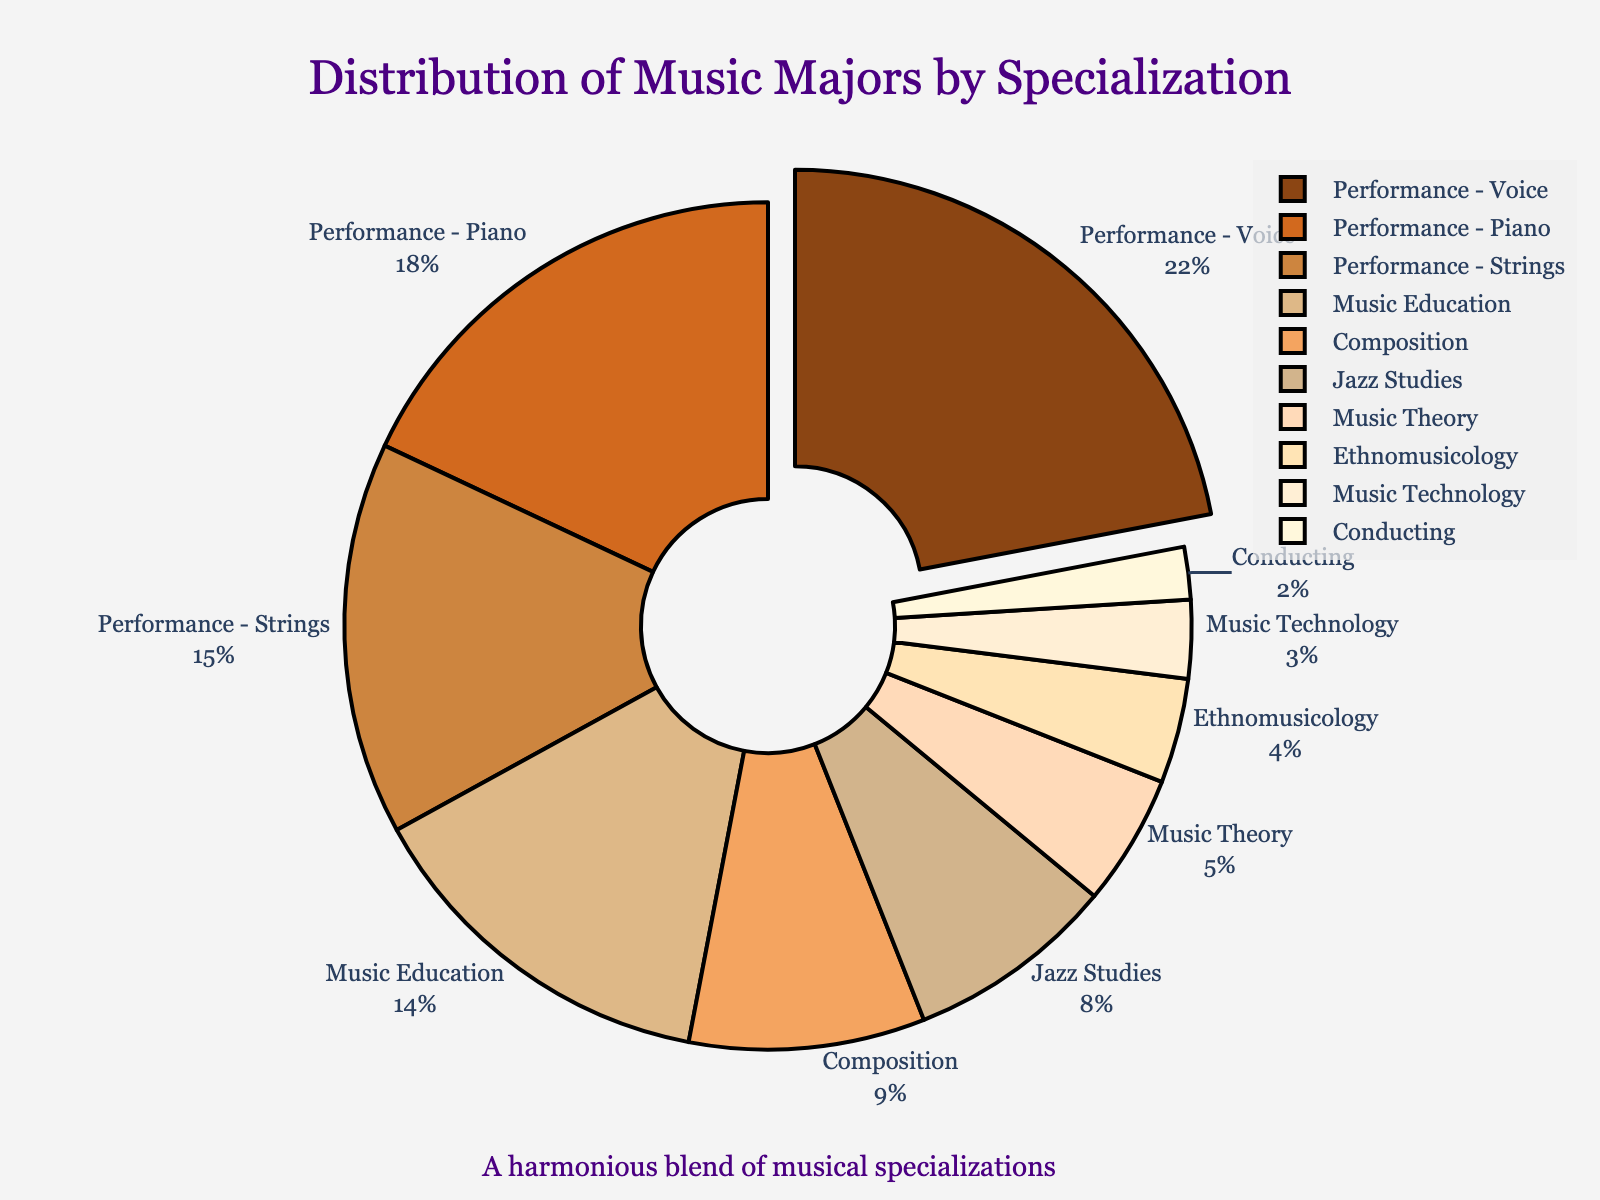Which specialization has the highest percentage of music majors? The figure highlights the largest section, which is Performance - Voice. The text information outside the pie also confirms this with 22%.
Answer: Performance - Voice Which specializations have a smaller percentage than Music Education? Music Education has 14%. Other specializations with percentages smaller than this are Composition (9%), Jazz Studies (8%), Music Theory (5%), Ethnomusicology (4%), Music Technology (3%), and Conducting (2%).
Answer: Composition, Jazz Studies, Music Theory, Ethnomusicology, Music Technology, Conducting How much more is the combined percentage of Performance - Voice and Performance - Piano compared to Jazz Studies? Performance - Voice is 22% and Performance - Piano is 18%, making a combined total of 40%. Jazz Studies is 8%, so the difference is 40% - 8% = 32%.
Answer: 32% How does the percentage of students in Music Theory compare to those in Jazz Studies? Music Theory has 5%, while Jazz Studies has 8%. Therefore, the percentage for Jazz Studies is higher.
Answer: Jazz Studies is higher What's the combined percentage of students in all performance-related specializations? The performance-related specializations are Voice (22%), Piano (18%), and Strings (15%). The combined percentage is 22% + 18% + 15% = 55%.
Answer: 55% Which specializations have a percentage that falls below 5%? Looking at the pie chart, specializations below 5% are Ethnomusicology (4%), Music Technology (3%), and Conducting (2%).
Answer: Ethnomusicology, Music Technology, Conducting By how much does the percentage of students in Composition exceed Conducting? Composition is 9%, and Conducting is 2%. The difference is 9% - 2% = 7%.
Answer: 7% If we combine the percentages of Music Theory and Ethnomusicology, how does it compare to Performance - Strings? Music Theory is 5%, and Ethnomusicology is 4%. Their combined percentage is 5% + 4% = 9%. Performance - Strings is 15%. Therefore, 15% - 9% = 6%, showing Performance - Strings exceeds the combined percentage by 6%.
Answer: Performance - Strings is higher by 6% Which portion of the pie chart is indicated as the most notable by being visually distinct? The largest portion, Performance - Voice at 22%, is pulled out from the pie chart for emphasis.
Answer: Performance - Voice 